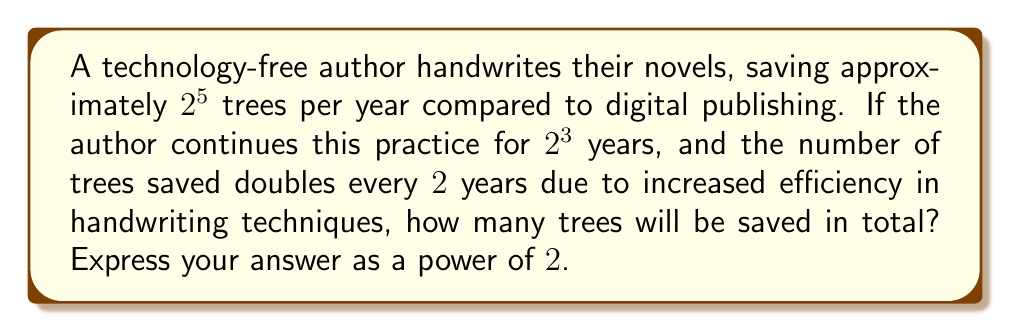Can you solve this math problem? Let's approach this step-by-step:

1) Initially, the author saves $2^5 = 32$ trees per year.

2) The practice continues for $2^3 = 8$ years.

3) The number of trees saved doubles every 2 years. This means there will be 4 doubling periods in 8 years.

4) We can represent this doubling as multiplying by $2^4$, since there are 4 doubling periods.

5) The total number of trees saved can be calculated as:
   $$ \text{Initial trees per year} \times \text{Number of years} \times \text{Doubling factor} $$

6) Substituting the values:
   $$ 2^5 \times 2^3 \times 2^4 $$

7) Using the laws of exponents, we can add the exponents:
   $$ 2^{5+3+4} = 2^{12} $$

Therefore, the total number of trees saved is $2^{12}$.
Answer: $2^{12}$ trees 